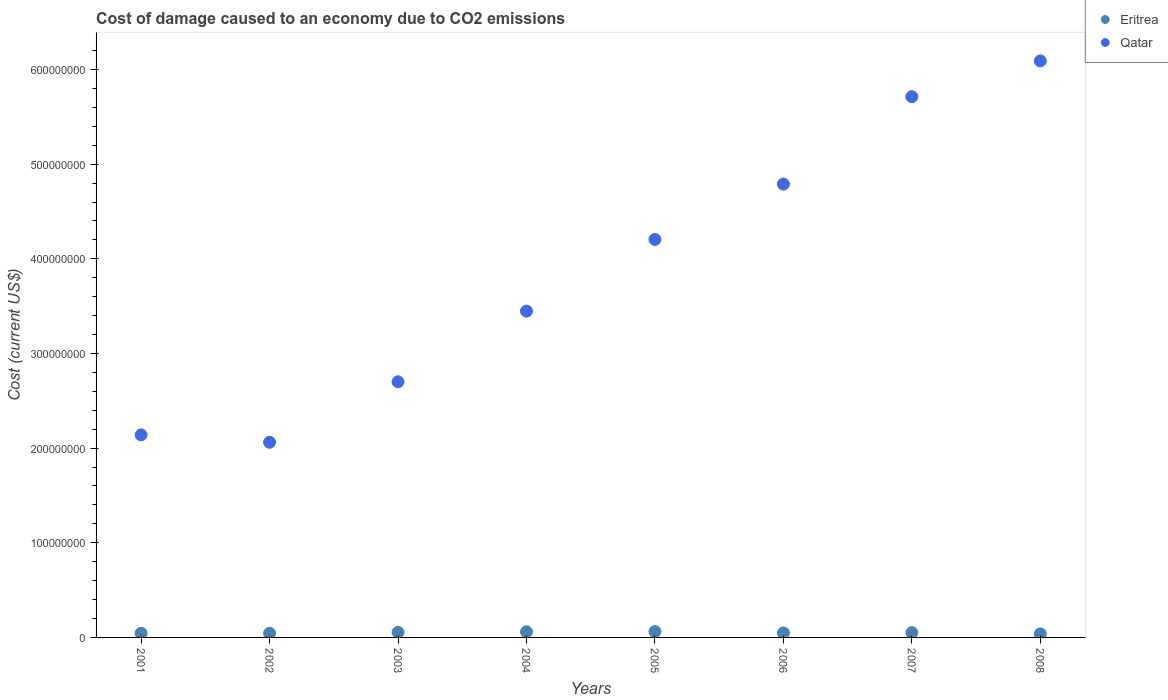How many different coloured dotlines are there?
Your answer should be very brief. 2. Is the number of dotlines equal to the number of legend labels?
Offer a very short reply. Yes. What is the cost of damage caused due to CO2 emissisons in Eritrea in 2002?
Your response must be concise. 4.38e+06. Across all years, what is the maximum cost of damage caused due to CO2 emissisons in Eritrea?
Your response must be concise. 6.21e+06. Across all years, what is the minimum cost of damage caused due to CO2 emissisons in Qatar?
Offer a very short reply. 2.06e+08. What is the total cost of damage caused due to CO2 emissisons in Qatar in the graph?
Your response must be concise. 3.12e+09. What is the difference between the cost of damage caused due to CO2 emissisons in Qatar in 2006 and that in 2007?
Your answer should be very brief. -9.24e+07. What is the difference between the cost of damage caused due to CO2 emissisons in Qatar in 2001 and the cost of damage caused due to CO2 emissisons in Eritrea in 2007?
Your answer should be very brief. 2.09e+08. What is the average cost of damage caused due to CO2 emissisons in Qatar per year?
Provide a succinct answer. 3.89e+08. In the year 2002, what is the difference between the cost of damage caused due to CO2 emissisons in Eritrea and cost of damage caused due to CO2 emissisons in Qatar?
Ensure brevity in your answer.  -2.02e+08. In how many years, is the cost of damage caused due to CO2 emissisons in Qatar greater than 460000000 US$?
Make the answer very short. 3. What is the ratio of the cost of damage caused due to CO2 emissisons in Eritrea in 2002 to that in 2006?
Keep it short and to the point. 0.92. Is the difference between the cost of damage caused due to CO2 emissisons in Eritrea in 2001 and 2008 greater than the difference between the cost of damage caused due to CO2 emissisons in Qatar in 2001 and 2008?
Make the answer very short. Yes. What is the difference between the highest and the second highest cost of damage caused due to CO2 emissisons in Qatar?
Your response must be concise. 3.78e+07. What is the difference between the highest and the lowest cost of damage caused due to CO2 emissisons in Eritrea?
Make the answer very short. 2.47e+06. In how many years, is the cost of damage caused due to CO2 emissisons in Qatar greater than the average cost of damage caused due to CO2 emissisons in Qatar taken over all years?
Your response must be concise. 4. Is the cost of damage caused due to CO2 emissisons in Qatar strictly greater than the cost of damage caused due to CO2 emissisons in Eritrea over the years?
Your answer should be compact. Yes. How many years are there in the graph?
Your response must be concise. 8. What is the difference between two consecutive major ticks on the Y-axis?
Make the answer very short. 1.00e+08. Does the graph contain any zero values?
Offer a very short reply. No. Does the graph contain grids?
Make the answer very short. No. What is the title of the graph?
Provide a succinct answer. Cost of damage caused to an economy due to CO2 emissions. What is the label or title of the X-axis?
Offer a terse response. Years. What is the label or title of the Y-axis?
Ensure brevity in your answer.  Cost (current US$). What is the Cost (current US$) in Eritrea in 2001?
Offer a terse response. 4.45e+06. What is the Cost (current US$) of Qatar in 2001?
Your answer should be very brief. 2.14e+08. What is the Cost (current US$) of Eritrea in 2002?
Offer a terse response. 4.38e+06. What is the Cost (current US$) in Qatar in 2002?
Your response must be concise. 2.06e+08. What is the Cost (current US$) in Eritrea in 2003?
Provide a succinct answer. 5.42e+06. What is the Cost (current US$) in Qatar in 2003?
Keep it short and to the point. 2.70e+08. What is the Cost (current US$) of Eritrea in 2004?
Your response must be concise. 5.98e+06. What is the Cost (current US$) in Qatar in 2004?
Make the answer very short. 3.45e+08. What is the Cost (current US$) in Eritrea in 2005?
Ensure brevity in your answer.  6.21e+06. What is the Cost (current US$) in Qatar in 2005?
Your answer should be very brief. 4.21e+08. What is the Cost (current US$) of Eritrea in 2006?
Make the answer very short. 4.74e+06. What is the Cost (current US$) of Qatar in 2006?
Your response must be concise. 4.79e+08. What is the Cost (current US$) in Eritrea in 2007?
Your response must be concise. 5.07e+06. What is the Cost (current US$) of Qatar in 2007?
Ensure brevity in your answer.  5.71e+08. What is the Cost (current US$) of Eritrea in 2008?
Provide a short and direct response. 3.74e+06. What is the Cost (current US$) in Qatar in 2008?
Make the answer very short. 6.09e+08. Across all years, what is the maximum Cost (current US$) in Eritrea?
Provide a short and direct response. 6.21e+06. Across all years, what is the maximum Cost (current US$) of Qatar?
Provide a short and direct response. 6.09e+08. Across all years, what is the minimum Cost (current US$) in Eritrea?
Give a very brief answer. 3.74e+06. Across all years, what is the minimum Cost (current US$) of Qatar?
Offer a very short reply. 2.06e+08. What is the total Cost (current US$) of Eritrea in the graph?
Offer a very short reply. 4.00e+07. What is the total Cost (current US$) in Qatar in the graph?
Give a very brief answer. 3.12e+09. What is the difference between the Cost (current US$) in Eritrea in 2001 and that in 2002?
Offer a very short reply. 6.45e+04. What is the difference between the Cost (current US$) of Qatar in 2001 and that in 2002?
Make the answer very short. 7.78e+06. What is the difference between the Cost (current US$) in Eritrea in 2001 and that in 2003?
Make the answer very short. -9.79e+05. What is the difference between the Cost (current US$) of Qatar in 2001 and that in 2003?
Offer a terse response. -5.61e+07. What is the difference between the Cost (current US$) in Eritrea in 2001 and that in 2004?
Keep it short and to the point. -1.54e+06. What is the difference between the Cost (current US$) of Qatar in 2001 and that in 2004?
Give a very brief answer. -1.31e+08. What is the difference between the Cost (current US$) of Eritrea in 2001 and that in 2005?
Your answer should be very brief. -1.77e+06. What is the difference between the Cost (current US$) in Qatar in 2001 and that in 2005?
Keep it short and to the point. -2.07e+08. What is the difference between the Cost (current US$) in Eritrea in 2001 and that in 2006?
Your answer should be compact. -2.91e+05. What is the difference between the Cost (current US$) of Qatar in 2001 and that in 2006?
Your answer should be very brief. -2.65e+08. What is the difference between the Cost (current US$) of Eritrea in 2001 and that in 2007?
Provide a short and direct response. -6.29e+05. What is the difference between the Cost (current US$) of Qatar in 2001 and that in 2007?
Provide a succinct answer. -3.57e+08. What is the difference between the Cost (current US$) in Eritrea in 2001 and that in 2008?
Your answer should be compact. 7.06e+05. What is the difference between the Cost (current US$) in Qatar in 2001 and that in 2008?
Offer a very short reply. -3.95e+08. What is the difference between the Cost (current US$) of Eritrea in 2002 and that in 2003?
Give a very brief answer. -1.04e+06. What is the difference between the Cost (current US$) in Qatar in 2002 and that in 2003?
Your response must be concise. -6.39e+07. What is the difference between the Cost (current US$) of Eritrea in 2002 and that in 2004?
Provide a short and direct response. -1.60e+06. What is the difference between the Cost (current US$) in Qatar in 2002 and that in 2004?
Give a very brief answer. -1.39e+08. What is the difference between the Cost (current US$) of Eritrea in 2002 and that in 2005?
Make the answer very short. -1.83e+06. What is the difference between the Cost (current US$) in Qatar in 2002 and that in 2005?
Provide a short and direct response. -2.14e+08. What is the difference between the Cost (current US$) in Eritrea in 2002 and that in 2006?
Provide a succinct answer. -3.56e+05. What is the difference between the Cost (current US$) of Qatar in 2002 and that in 2006?
Give a very brief answer. -2.73e+08. What is the difference between the Cost (current US$) in Eritrea in 2002 and that in 2007?
Provide a succinct answer. -6.94e+05. What is the difference between the Cost (current US$) of Qatar in 2002 and that in 2007?
Your response must be concise. -3.65e+08. What is the difference between the Cost (current US$) in Eritrea in 2002 and that in 2008?
Give a very brief answer. 6.41e+05. What is the difference between the Cost (current US$) of Qatar in 2002 and that in 2008?
Ensure brevity in your answer.  -4.03e+08. What is the difference between the Cost (current US$) in Eritrea in 2003 and that in 2004?
Give a very brief answer. -5.56e+05. What is the difference between the Cost (current US$) in Qatar in 2003 and that in 2004?
Offer a terse response. -7.47e+07. What is the difference between the Cost (current US$) in Eritrea in 2003 and that in 2005?
Your answer should be compact. -7.87e+05. What is the difference between the Cost (current US$) in Qatar in 2003 and that in 2005?
Provide a short and direct response. -1.50e+08. What is the difference between the Cost (current US$) in Eritrea in 2003 and that in 2006?
Offer a terse response. 6.88e+05. What is the difference between the Cost (current US$) in Qatar in 2003 and that in 2006?
Offer a terse response. -2.09e+08. What is the difference between the Cost (current US$) in Eritrea in 2003 and that in 2007?
Your answer should be compact. 3.50e+05. What is the difference between the Cost (current US$) of Qatar in 2003 and that in 2007?
Offer a very short reply. -3.01e+08. What is the difference between the Cost (current US$) of Eritrea in 2003 and that in 2008?
Offer a very short reply. 1.69e+06. What is the difference between the Cost (current US$) in Qatar in 2003 and that in 2008?
Ensure brevity in your answer.  -3.39e+08. What is the difference between the Cost (current US$) of Eritrea in 2004 and that in 2005?
Your answer should be compact. -2.31e+05. What is the difference between the Cost (current US$) in Qatar in 2004 and that in 2005?
Provide a succinct answer. -7.57e+07. What is the difference between the Cost (current US$) in Eritrea in 2004 and that in 2006?
Ensure brevity in your answer.  1.24e+06. What is the difference between the Cost (current US$) of Qatar in 2004 and that in 2006?
Give a very brief answer. -1.34e+08. What is the difference between the Cost (current US$) in Eritrea in 2004 and that in 2007?
Keep it short and to the point. 9.07e+05. What is the difference between the Cost (current US$) in Qatar in 2004 and that in 2007?
Offer a very short reply. -2.27e+08. What is the difference between the Cost (current US$) of Eritrea in 2004 and that in 2008?
Your answer should be compact. 2.24e+06. What is the difference between the Cost (current US$) in Qatar in 2004 and that in 2008?
Your response must be concise. -2.64e+08. What is the difference between the Cost (current US$) of Eritrea in 2005 and that in 2006?
Ensure brevity in your answer.  1.48e+06. What is the difference between the Cost (current US$) in Qatar in 2005 and that in 2006?
Give a very brief answer. -5.85e+07. What is the difference between the Cost (current US$) in Eritrea in 2005 and that in 2007?
Provide a short and direct response. 1.14e+06. What is the difference between the Cost (current US$) in Qatar in 2005 and that in 2007?
Ensure brevity in your answer.  -1.51e+08. What is the difference between the Cost (current US$) of Eritrea in 2005 and that in 2008?
Keep it short and to the point. 2.47e+06. What is the difference between the Cost (current US$) in Qatar in 2005 and that in 2008?
Keep it short and to the point. -1.89e+08. What is the difference between the Cost (current US$) of Eritrea in 2006 and that in 2007?
Your answer should be very brief. -3.38e+05. What is the difference between the Cost (current US$) in Qatar in 2006 and that in 2007?
Provide a short and direct response. -9.24e+07. What is the difference between the Cost (current US$) in Eritrea in 2006 and that in 2008?
Offer a terse response. 9.97e+05. What is the difference between the Cost (current US$) of Qatar in 2006 and that in 2008?
Offer a terse response. -1.30e+08. What is the difference between the Cost (current US$) in Eritrea in 2007 and that in 2008?
Your answer should be compact. 1.34e+06. What is the difference between the Cost (current US$) in Qatar in 2007 and that in 2008?
Offer a terse response. -3.78e+07. What is the difference between the Cost (current US$) in Eritrea in 2001 and the Cost (current US$) in Qatar in 2002?
Offer a very short reply. -2.02e+08. What is the difference between the Cost (current US$) of Eritrea in 2001 and the Cost (current US$) of Qatar in 2003?
Your response must be concise. -2.66e+08. What is the difference between the Cost (current US$) in Eritrea in 2001 and the Cost (current US$) in Qatar in 2004?
Ensure brevity in your answer.  -3.40e+08. What is the difference between the Cost (current US$) in Eritrea in 2001 and the Cost (current US$) in Qatar in 2005?
Your answer should be very brief. -4.16e+08. What is the difference between the Cost (current US$) of Eritrea in 2001 and the Cost (current US$) of Qatar in 2006?
Provide a succinct answer. -4.75e+08. What is the difference between the Cost (current US$) in Eritrea in 2001 and the Cost (current US$) in Qatar in 2007?
Your answer should be very brief. -5.67e+08. What is the difference between the Cost (current US$) in Eritrea in 2001 and the Cost (current US$) in Qatar in 2008?
Provide a short and direct response. -6.05e+08. What is the difference between the Cost (current US$) of Eritrea in 2002 and the Cost (current US$) of Qatar in 2003?
Your response must be concise. -2.66e+08. What is the difference between the Cost (current US$) of Eritrea in 2002 and the Cost (current US$) of Qatar in 2004?
Your response must be concise. -3.40e+08. What is the difference between the Cost (current US$) in Eritrea in 2002 and the Cost (current US$) in Qatar in 2005?
Give a very brief answer. -4.16e+08. What is the difference between the Cost (current US$) of Eritrea in 2002 and the Cost (current US$) of Qatar in 2006?
Make the answer very short. -4.75e+08. What is the difference between the Cost (current US$) in Eritrea in 2002 and the Cost (current US$) in Qatar in 2007?
Give a very brief answer. -5.67e+08. What is the difference between the Cost (current US$) of Eritrea in 2002 and the Cost (current US$) of Qatar in 2008?
Make the answer very short. -6.05e+08. What is the difference between the Cost (current US$) in Eritrea in 2003 and the Cost (current US$) in Qatar in 2004?
Your answer should be very brief. -3.39e+08. What is the difference between the Cost (current US$) in Eritrea in 2003 and the Cost (current US$) in Qatar in 2005?
Ensure brevity in your answer.  -4.15e+08. What is the difference between the Cost (current US$) of Eritrea in 2003 and the Cost (current US$) of Qatar in 2006?
Provide a short and direct response. -4.74e+08. What is the difference between the Cost (current US$) of Eritrea in 2003 and the Cost (current US$) of Qatar in 2007?
Provide a succinct answer. -5.66e+08. What is the difference between the Cost (current US$) of Eritrea in 2003 and the Cost (current US$) of Qatar in 2008?
Offer a terse response. -6.04e+08. What is the difference between the Cost (current US$) of Eritrea in 2004 and the Cost (current US$) of Qatar in 2005?
Ensure brevity in your answer.  -4.15e+08. What is the difference between the Cost (current US$) of Eritrea in 2004 and the Cost (current US$) of Qatar in 2006?
Provide a succinct answer. -4.73e+08. What is the difference between the Cost (current US$) of Eritrea in 2004 and the Cost (current US$) of Qatar in 2007?
Keep it short and to the point. -5.65e+08. What is the difference between the Cost (current US$) in Eritrea in 2004 and the Cost (current US$) in Qatar in 2008?
Keep it short and to the point. -6.03e+08. What is the difference between the Cost (current US$) of Eritrea in 2005 and the Cost (current US$) of Qatar in 2006?
Your response must be concise. -4.73e+08. What is the difference between the Cost (current US$) of Eritrea in 2005 and the Cost (current US$) of Qatar in 2007?
Provide a short and direct response. -5.65e+08. What is the difference between the Cost (current US$) in Eritrea in 2005 and the Cost (current US$) in Qatar in 2008?
Give a very brief answer. -6.03e+08. What is the difference between the Cost (current US$) in Eritrea in 2006 and the Cost (current US$) in Qatar in 2007?
Keep it short and to the point. -5.67e+08. What is the difference between the Cost (current US$) in Eritrea in 2006 and the Cost (current US$) in Qatar in 2008?
Give a very brief answer. -6.04e+08. What is the difference between the Cost (current US$) of Eritrea in 2007 and the Cost (current US$) of Qatar in 2008?
Make the answer very short. -6.04e+08. What is the average Cost (current US$) in Eritrea per year?
Offer a very short reply. 5.00e+06. What is the average Cost (current US$) of Qatar per year?
Ensure brevity in your answer.  3.89e+08. In the year 2001, what is the difference between the Cost (current US$) of Eritrea and Cost (current US$) of Qatar?
Your answer should be very brief. -2.10e+08. In the year 2002, what is the difference between the Cost (current US$) in Eritrea and Cost (current US$) in Qatar?
Give a very brief answer. -2.02e+08. In the year 2003, what is the difference between the Cost (current US$) of Eritrea and Cost (current US$) of Qatar?
Give a very brief answer. -2.65e+08. In the year 2004, what is the difference between the Cost (current US$) in Eritrea and Cost (current US$) in Qatar?
Provide a succinct answer. -3.39e+08. In the year 2005, what is the difference between the Cost (current US$) in Eritrea and Cost (current US$) in Qatar?
Offer a very short reply. -4.14e+08. In the year 2006, what is the difference between the Cost (current US$) in Eritrea and Cost (current US$) in Qatar?
Provide a succinct answer. -4.74e+08. In the year 2007, what is the difference between the Cost (current US$) of Eritrea and Cost (current US$) of Qatar?
Your answer should be very brief. -5.66e+08. In the year 2008, what is the difference between the Cost (current US$) in Eritrea and Cost (current US$) in Qatar?
Make the answer very short. -6.05e+08. What is the ratio of the Cost (current US$) of Eritrea in 2001 to that in 2002?
Your answer should be compact. 1.01. What is the ratio of the Cost (current US$) in Qatar in 2001 to that in 2002?
Give a very brief answer. 1.04. What is the ratio of the Cost (current US$) in Eritrea in 2001 to that in 2003?
Keep it short and to the point. 0.82. What is the ratio of the Cost (current US$) in Qatar in 2001 to that in 2003?
Your answer should be compact. 0.79. What is the ratio of the Cost (current US$) of Eritrea in 2001 to that in 2004?
Keep it short and to the point. 0.74. What is the ratio of the Cost (current US$) in Qatar in 2001 to that in 2004?
Your response must be concise. 0.62. What is the ratio of the Cost (current US$) of Eritrea in 2001 to that in 2005?
Keep it short and to the point. 0.72. What is the ratio of the Cost (current US$) of Qatar in 2001 to that in 2005?
Provide a short and direct response. 0.51. What is the ratio of the Cost (current US$) of Eritrea in 2001 to that in 2006?
Offer a very short reply. 0.94. What is the ratio of the Cost (current US$) in Qatar in 2001 to that in 2006?
Provide a short and direct response. 0.45. What is the ratio of the Cost (current US$) in Eritrea in 2001 to that in 2007?
Offer a terse response. 0.88. What is the ratio of the Cost (current US$) of Qatar in 2001 to that in 2007?
Your response must be concise. 0.37. What is the ratio of the Cost (current US$) of Eritrea in 2001 to that in 2008?
Keep it short and to the point. 1.19. What is the ratio of the Cost (current US$) in Qatar in 2001 to that in 2008?
Ensure brevity in your answer.  0.35. What is the ratio of the Cost (current US$) of Eritrea in 2002 to that in 2003?
Offer a terse response. 0.81. What is the ratio of the Cost (current US$) in Qatar in 2002 to that in 2003?
Make the answer very short. 0.76. What is the ratio of the Cost (current US$) of Eritrea in 2002 to that in 2004?
Keep it short and to the point. 0.73. What is the ratio of the Cost (current US$) of Qatar in 2002 to that in 2004?
Your response must be concise. 0.6. What is the ratio of the Cost (current US$) in Eritrea in 2002 to that in 2005?
Your response must be concise. 0.71. What is the ratio of the Cost (current US$) of Qatar in 2002 to that in 2005?
Provide a succinct answer. 0.49. What is the ratio of the Cost (current US$) of Eritrea in 2002 to that in 2006?
Provide a succinct answer. 0.92. What is the ratio of the Cost (current US$) of Qatar in 2002 to that in 2006?
Ensure brevity in your answer.  0.43. What is the ratio of the Cost (current US$) of Eritrea in 2002 to that in 2007?
Keep it short and to the point. 0.86. What is the ratio of the Cost (current US$) of Qatar in 2002 to that in 2007?
Your response must be concise. 0.36. What is the ratio of the Cost (current US$) of Eritrea in 2002 to that in 2008?
Your answer should be very brief. 1.17. What is the ratio of the Cost (current US$) in Qatar in 2002 to that in 2008?
Ensure brevity in your answer.  0.34. What is the ratio of the Cost (current US$) in Eritrea in 2003 to that in 2004?
Offer a terse response. 0.91. What is the ratio of the Cost (current US$) in Qatar in 2003 to that in 2004?
Offer a terse response. 0.78. What is the ratio of the Cost (current US$) of Eritrea in 2003 to that in 2005?
Make the answer very short. 0.87. What is the ratio of the Cost (current US$) of Qatar in 2003 to that in 2005?
Your response must be concise. 0.64. What is the ratio of the Cost (current US$) in Eritrea in 2003 to that in 2006?
Offer a terse response. 1.15. What is the ratio of the Cost (current US$) in Qatar in 2003 to that in 2006?
Your answer should be very brief. 0.56. What is the ratio of the Cost (current US$) in Eritrea in 2003 to that in 2007?
Provide a short and direct response. 1.07. What is the ratio of the Cost (current US$) of Qatar in 2003 to that in 2007?
Offer a very short reply. 0.47. What is the ratio of the Cost (current US$) of Eritrea in 2003 to that in 2008?
Keep it short and to the point. 1.45. What is the ratio of the Cost (current US$) in Qatar in 2003 to that in 2008?
Your response must be concise. 0.44. What is the ratio of the Cost (current US$) in Eritrea in 2004 to that in 2005?
Provide a short and direct response. 0.96. What is the ratio of the Cost (current US$) of Qatar in 2004 to that in 2005?
Provide a succinct answer. 0.82. What is the ratio of the Cost (current US$) in Eritrea in 2004 to that in 2006?
Your answer should be compact. 1.26. What is the ratio of the Cost (current US$) in Qatar in 2004 to that in 2006?
Give a very brief answer. 0.72. What is the ratio of the Cost (current US$) in Eritrea in 2004 to that in 2007?
Make the answer very short. 1.18. What is the ratio of the Cost (current US$) of Qatar in 2004 to that in 2007?
Your response must be concise. 0.6. What is the ratio of the Cost (current US$) of Eritrea in 2004 to that in 2008?
Your answer should be very brief. 1.6. What is the ratio of the Cost (current US$) in Qatar in 2004 to that in 2008?
Your response must be concise. 0.57. What is the ratio of the Cost (current US$) of Eritrea in 2005 to that in 2006?
Provide a succinct answer. 1.31. What is the ratio of the Cost (current US$) of Qatar in 2005 to that in 2006?
Your response must be concise. 0.88. What is the ratio of the Cost (current US$) of Eritrea in 2005 to that in 2007?
Offer a very short reply. 1.22. What is the ratio of the Cost (current US$) of Qatar in 2005 to that in 2007?
Make the answer very short. 0.74. What is the ratio of the Cost (current US$) of Eritrea in 2005 to that in 2008?
Your answer should be compact. 1.66. What is the ratio of the Cost (current US$) in Qatar in 2005 to that in 2008?
Your answer should be very brief. 0.69. What is the ratio of the Cost (current US$) in Eritrea in 2006 to that in 2007?
Provide a short and direct response. 0.93. What is the ratio of the Cost (current US$) in Qatar in 2006 to that in 2007?
Your answer should be compact. 0.84. What is the ratio of the Cost (current US$) of Eritrea in 2006 to that in 2008?
Your answer should be very brief. 1.27. What is the ratio of the Cost (current US$) of Qatar in 2006 to that in 2008?
Give a very brief answer. 0.79. What is the ratio of the Cost (current US$) of Eritrea in 2007 to that in 2008?
Make the answer very short. 1.36. What is the ratio of the Cost (current US$) in Qatar in 2007 to that in 2008?
Ensure brevity in your answer.  0.94. What is the difference between the highest and the second highest Cost (current US$) of Eritrea?
Your answer should be compact. 2.31e+05. What is the difference between the highest and the second highest Cost (current US$) of Qatar?
Ensure brevity in your answer.  3.78e+07. What is the difference between the highest and the lowest Cost (current US$) in Eritrea?
Make the answer very short. 2.47e+06. What is the difference between the highest and the lowest Cost (current US$) in Qatar?
Keep it short and to the point. 4.03e+08. 